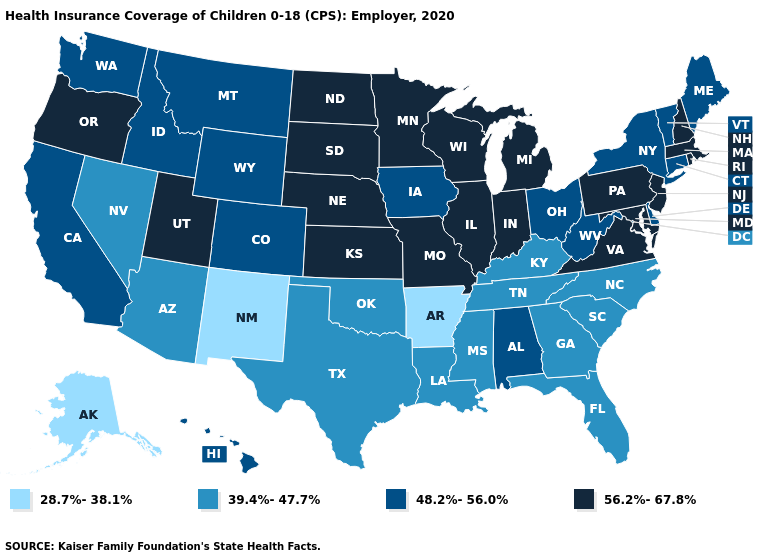Does Hawaii have the lowest value in the West?
Write a very short answer. No. Among the states that border Virginia , does Maryland have the highest value?
Short answer required. Yes. Does New Mexico have the lowest value in the USA?
Short answer required. Yes. Among the states that border Missouri , which have the lowest value?
Concise answer only. Arkansas. Which states hav the highest value in the West?
Be succinct. Oregon, Utah. What is the highest value in the USA?
Concise answer only. 56.2%-67.8%. Which states have the highest value in the USA?
Answer briefly. Illinois, Indiana, Kansas, Maryland, Massachusetts, Michigan, Minnesota, Missouri, Nebraska, New Hampshire, New Jersey, North Dakota, Oregon, Pennsylvania, Rhode Island, South Dakota, Utah, Virginia, Wisconsin. Name the states that have a value in the range 48.2%-56.0%?
Write a very short answer. Alabama, California, Colorado, Connecticut, Delaware, Hawaii, Idaho, Iowa, Maine, Montana, New York, Ohio, Vermont, Washington, West Virginia, Wyoming. How many symbols are there in the legend?
Answer briefly. 4. Among the states that border Wyoming , does Utah have the highest value?
Concise answer only. Yes. What is the value of Massachusetts?
Give a very brief answer. 56.2%-67.8%. Name the states that have a value in the range 28.7%-38.1%?
Answer briefly. Alaska, Arkansas, New Mexico. Which states hav the highest value in the Northeast?
Concise answer only. Massachusetts, New Hampshire, New Jersey, Pennsylvania, Rhode Island. Does Colorado have a lower value than Minnesota?
Write a very short answer. Yes. What is the value of Texas?
Write a very short answer. 39.4%-47.7%. 